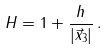<formula> <loc_0><loc_0><loc_500><loc_500>H = 1 + \frac { h } { | \vec { x } _ { 3 } | } \, .</formula> 